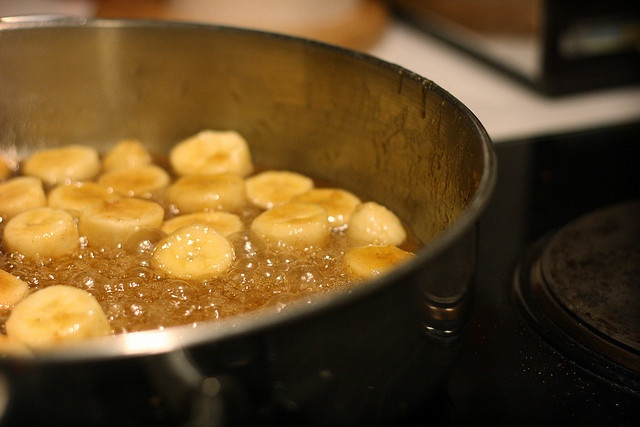Describe the objects in this image and their specific colors. I can see bowl in gray, black, maroon, olive, and orange tones, banana in gray, orange, tan, and olive tones, banana in gray, orange, and olive tones, banana in gray, gold, orange, and khaki tones, and banana in gray, orange, olive, and tan tones in this image. 